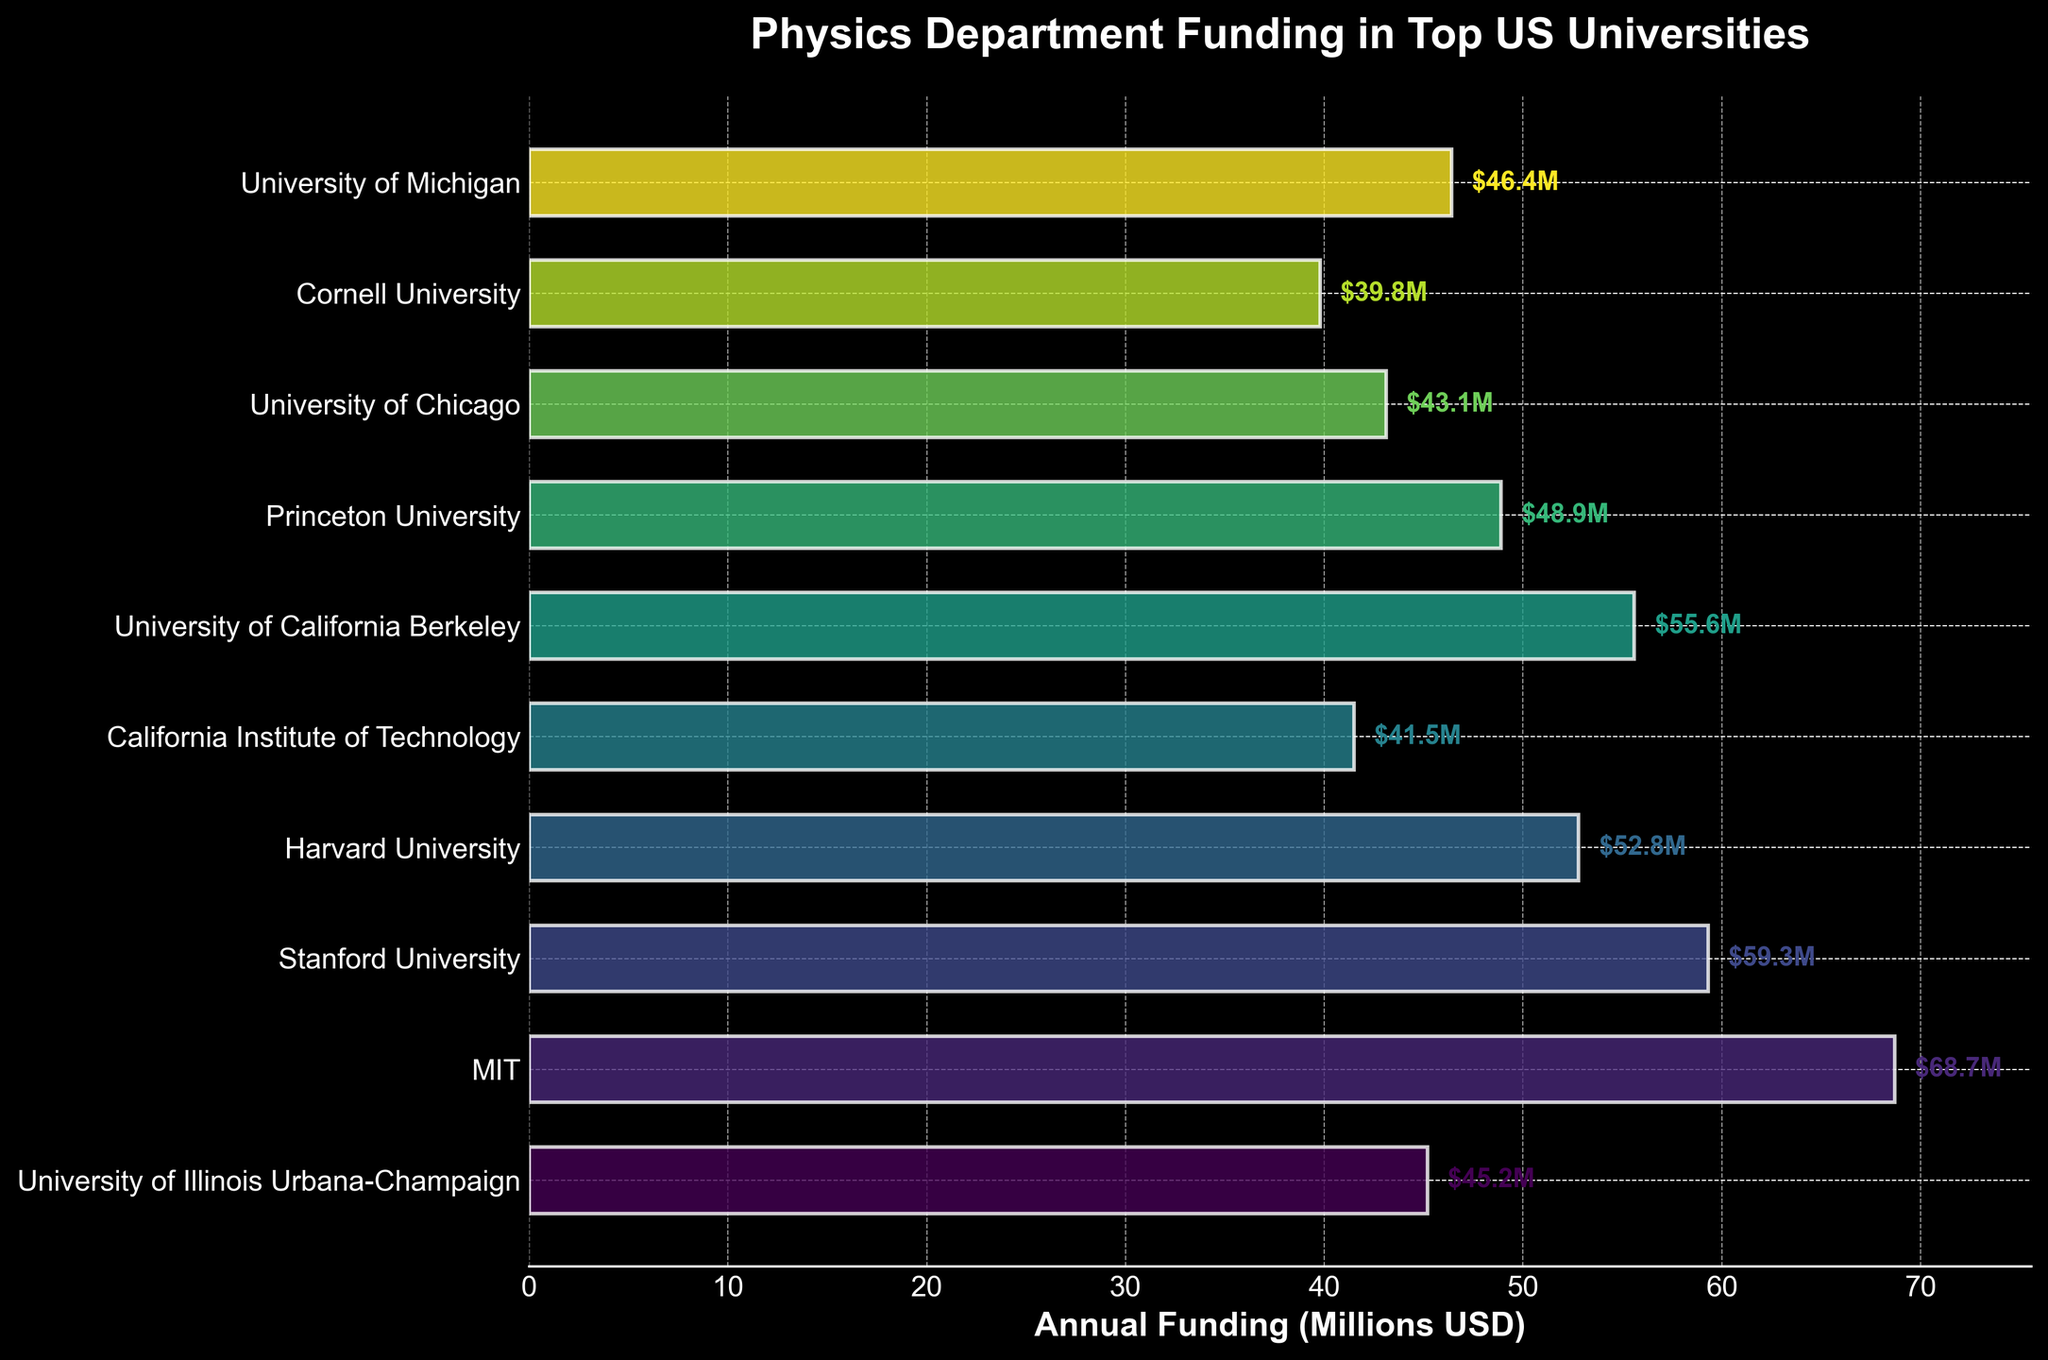What's the title of the plot? The title is located at the top of the plot, displayed in large, bold text. It reads 'Physics Department Funding in Top US Universities'.
Answer: Physics Department Funding in Top US Universities Which university has the highest annual funding? By observing the lengths of the bars in the horizontal bar plot, the longest bar represents MIT, indicating it has the highest funding.
Answer: MIT How much more funding does MIT have compared to Harvard University? MIT has $68.7M, and Harvard has $52.8M. Subtract Harvard's funding from MIT's: $68.7M - $52.8M = $15.9M.
Answer: $15.9M What is the median annual funding value among these universities? To find the median, first, list the funding values in ascending order: $39.8M, $41.5M, $43.1M, $45.2M, $46.4M, $48.9M, $52.8M, $55.6M, $59.3M, $68.7M. The median is the average of the 5th and 6th values: ($46.4M + $48.9M) / 2 = $47.65M.
Answer: $47.65M Which university has the least annual funding? The shortest bar in the plot represents Cornell University, indicating it has the lowest funding.
Answer: Cornell University How many universities have annual funding above $50M? By examining the bars and their corresponding values, the universities with funding above $50M are MIT, Stanford, Harvard, and University of California Berkeley. There are 4 such universities.
Answer: 4 What is the combined annual funding of the top three funded universities? The top three universities by funding are MIT ($68.7M), Stanford ($59.3M), and University of California Berkeley ($55.6M). Calculate the sum: $68.7M + $59.3M + $55.6M = $183.6M.
Answer: $183.6M Which two universities have funding amounts closest to each other? By comparing the difference in funding amounts for each pair, University of Illinois Urbana-Champaign has $45.2M and University of Michigan has $46.4M, with a difference of only $1.2M. This is the smallest difference between any two universities.
Answer: University of Illinois Urbana-Champaign and University of Michigan What is the average annual funding for all universities in the plot? Sum all the funding values: $45.2M + $68.7M + $59.3M + $52.8M + $41.5M + $55.6M + $48.9M + $43.1M + $39.8M + $46.4M = $501.3M. Divide by the number of universities (10): $501.3M / 10 = $50.13M.
Answer: $50.13M 